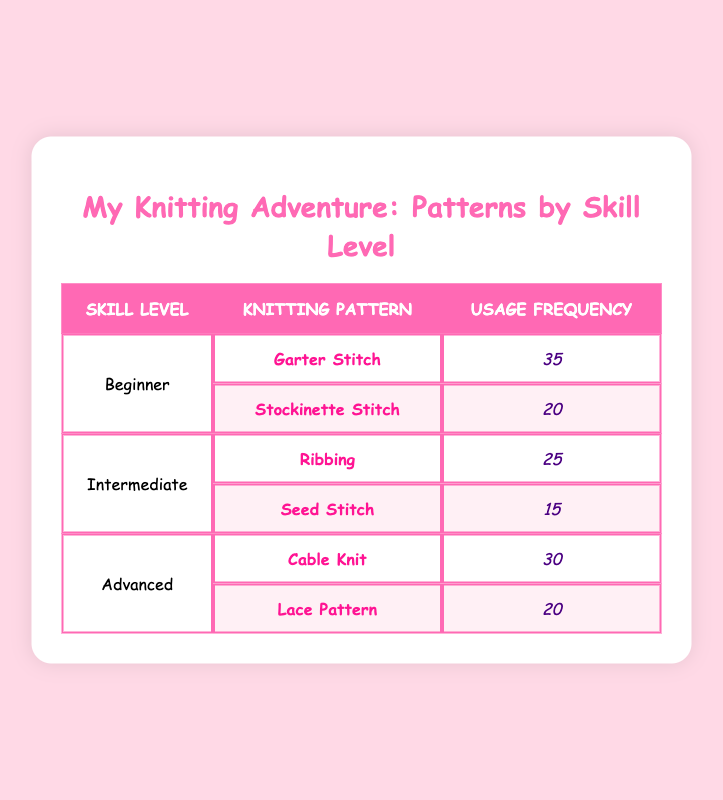What is the knitting pattern most frequently used by beginners? From the table, we can see that the usage frequency for the Garter Stitch, which is the knitting pattern for beginners, is 35. This is higher than Stockinette Stitch, which has a frequency of 20. Therefore, Garter Stitch is the most frequently used pattern for beginners.
Answer: Garter Stitch Which knitting pattern is used least by intermediate knitters? Looking at the intermediate skill level, the Seed Stitch has a usage frequency of 15, which is less than Ribbing, which has a frequency of 25. So, Seed Stitch is the least used pattern among intermediate knitters.
Answer: Seed Stitch True or False: Advanced knitters use more Garter Stitch patterns compared to intermediate knitters. The Garter Stitch is only mentioned in the Beginner category, with a frequency of 35, while the intermediate knitters only use the Ribbing and Seed Stitch patterns. Therefore, it’s false that advanced knitters use more Garter Stitch patterns since this pattern is not used by them at all.
Answer: False What is the total frequency of knitting patterns used by advanced knitters? The two patterns for advanced knitters are Cable Knit with a frequency of 30 and Lace Pattern with a frequency of 20. Adding them together: 30 + 20 equals 50. This means that the total frequency of knitting patterns used by advanced knitters is 50.
Answer: 50 Which skill level has the highest total usage frequency? To find which skill level has the highest total frequency, we can sum the usage frequencies for each level. For beginners, it is 35 + 20 = 55. For intermediate, it is 25 + 15 = 40. For advanced, it is 30 + 20 = 50. Since 55 is the highest total, beginners have the highest total usage frequency.
Answer: Beginner 